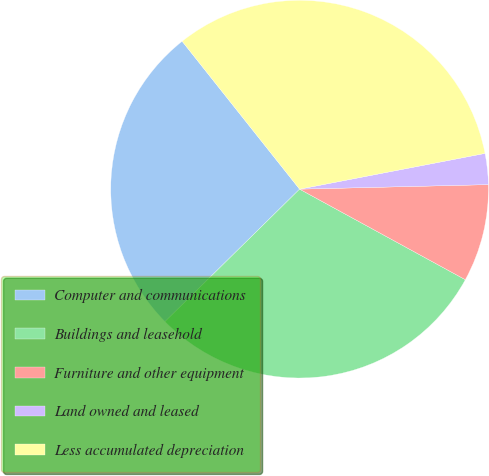Convert chart to OTSL. <chart><loc_0><loc_0><loc_500><loc_500><pie_chart><fcel>Computer and communications<fcel>Buildings and leasehold<fcel>Furniture and other equipment<fcel>Land owned and leased<fcel>Less accumulated depreciation<nl><fcel>26.69%<fcel>29.67%<fcel>8.34%<fcel>2.65%<fcel>32.65%<nl></chart> 